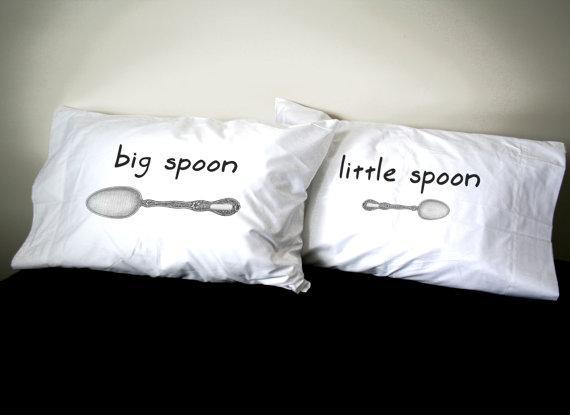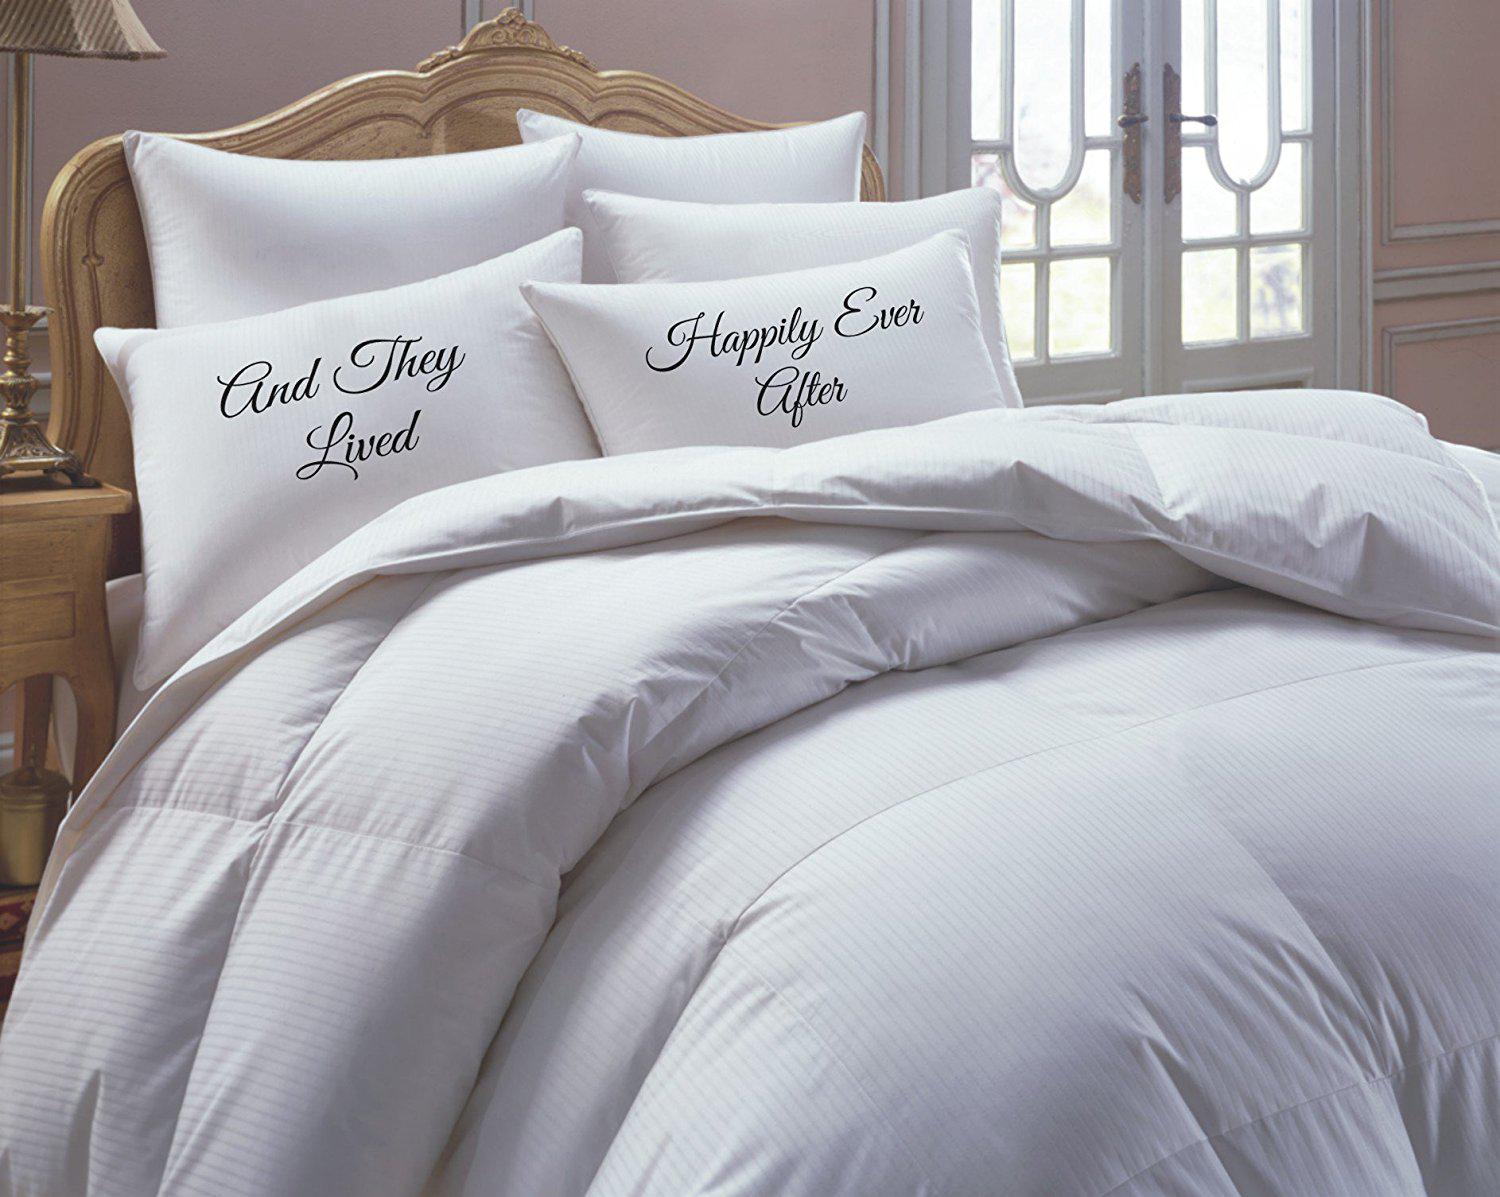The first image is the image on the left, the second image is the image on the right. For the images displayed, is the sentence "A pair of pillows are side-by-side on a bed and printed with spoon shapes below lettering." factually correct? Answer yes or no. Yes. The first image is the image on the left, the second image is the image on the right. For the images displayed, is the sentence "Each image shows a set of white pillows angled upward at the head of a bed, each set with the same saying but a different letter design." factually correct? Answer yes or no. No. 